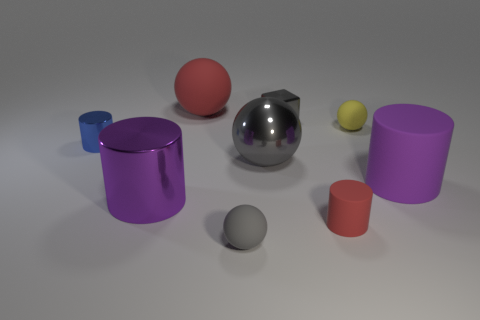Subtract all blue metal cylinders. How many cylinders are left? 3 Subtract 1 cylinders. How many cylinders are left? 3 Subtract all red cylinders. How many cylinders are left? 3 Subtract all brown spheres. Subtract all yellow cubes. How many spheres are left? 4 Subtract all cubes. How many objects are left? 8 Add 3 big gray shiny spheres. How many big gray shiny spheres are left? 4 Add 7 tiny brown shiny cylinders. How many tiny brown shiny cylinders exist? 7 Subtract 1 red cylinders. How many objects are left? 8 Subtract all tiny red cylinders. Subtract all purple cylinders. How many objects are left? 6 